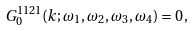Convert formula to latex. <formula><loc_0><loc_0><loc_500><loc_500>G _ { 0 } ^ { 1 1 2 1 } ( k ; \omega _ { 1 } , \omega _ { 2 } , \omega _ { 3 } , \omega _ { 4 } ) = 0 \, ,</formula> 